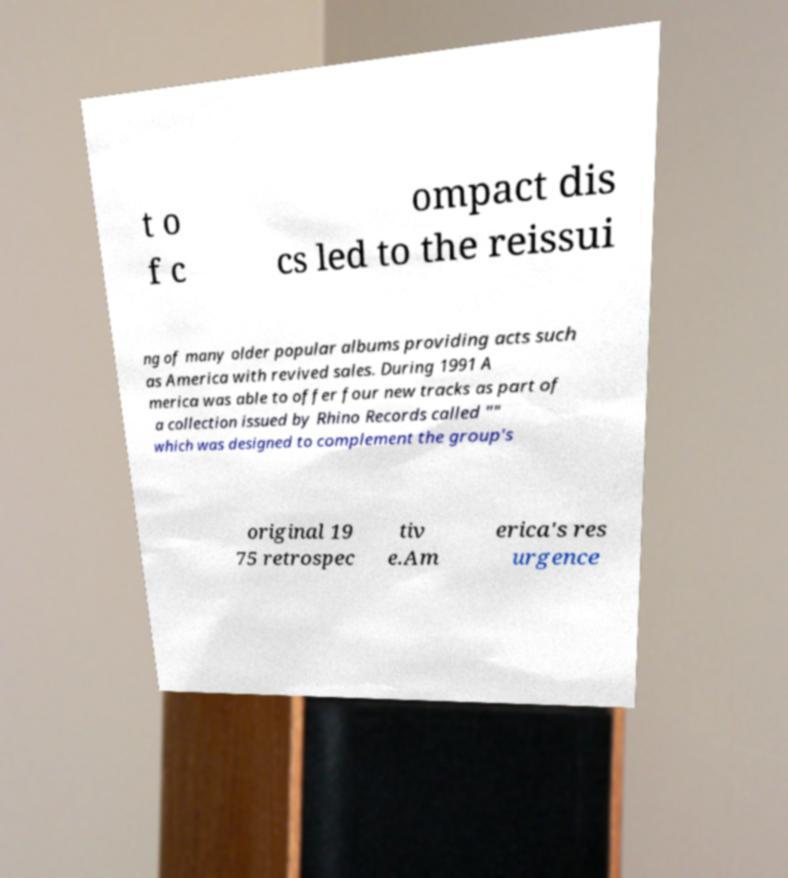There's text embedded in this image that I need extracted. Can you transcribe it verbatim? t o f c ompact dis cs led to the reissui ng of many older popular albums providing acts such as America with revived sales. During 1991 A merica was able to offer four new tracks as part of a collection issued by Rhino Records called "" which was designed to complement the group's original 19 75 retrospec tiv e.Am erica's res urgence 